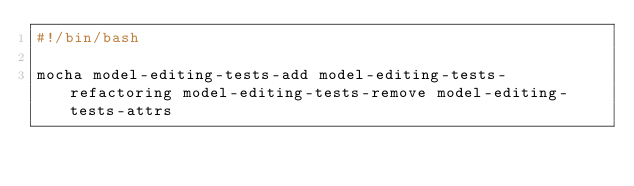Convert code to text. <code><loc_0><loc_0><loc_500><loc_500><_Bash_>#!/bin/bash

mocha model-editing-tests-add model-editing-tests-refactoring model-editing-tests-remove model-editing-tests-attrs
</code> 